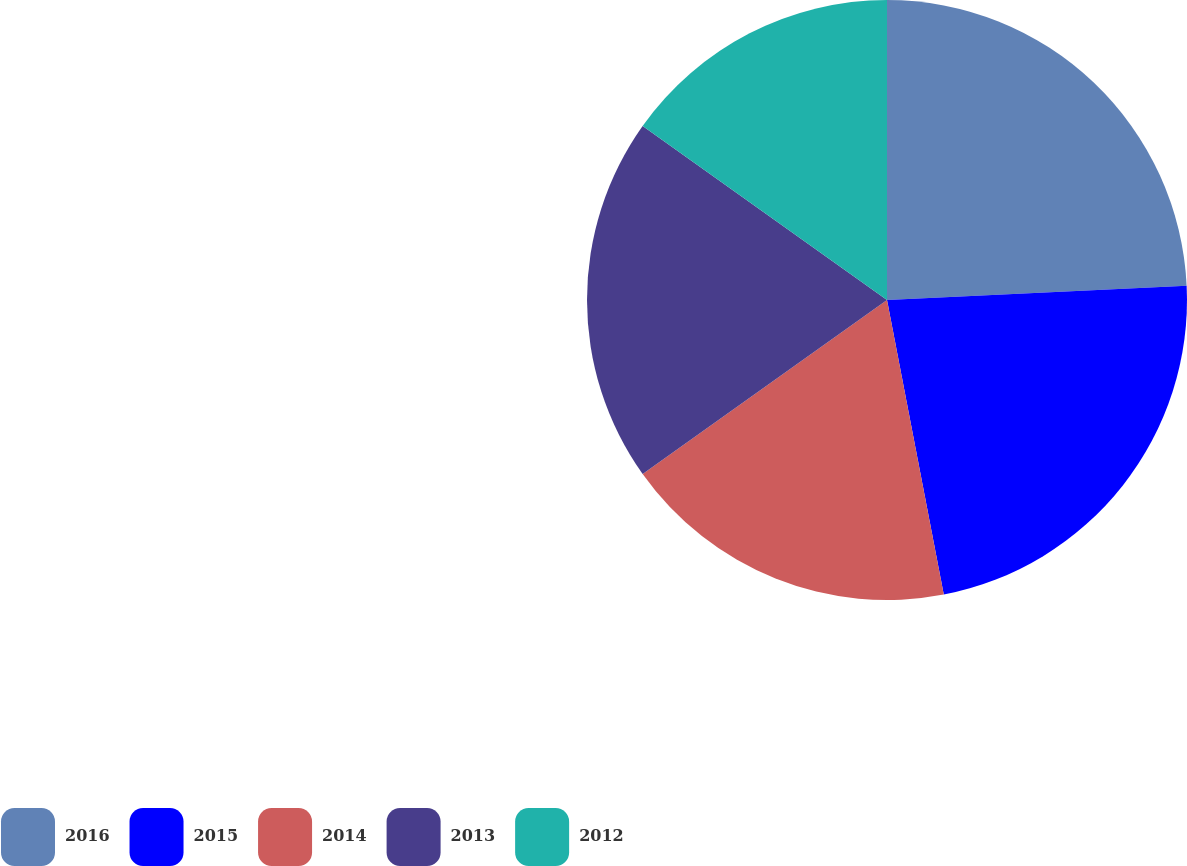<chart> <loc_0><loc_0><loc_500><loc_500><pie_chart><fcel>2016<fcel>2015<fcel>2014<fcel>2013<fcel>2012<nl><fcel>24.24%<fcel>22.73%<fcel>18.18%<fcel>19.7%<fcel>15.15%<nl></chart> 